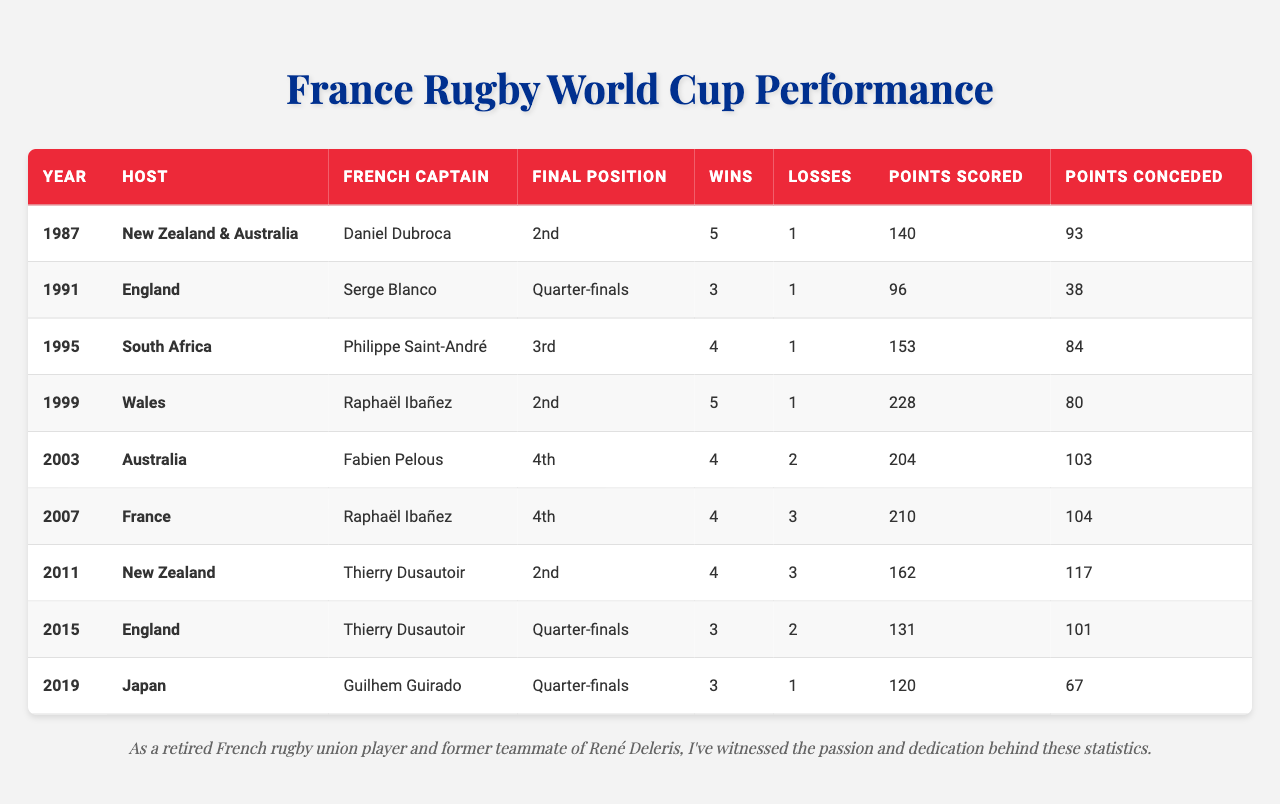What position did France finish in the 1995 Rugby World Cup? In the table, the Final Position for the year 1995 is listed as "3rd."
Answer: 3rd Which year did France score the most points in a Rugby World Cup? Looking at the Points Scored column, the highest value is 228 points in the year 1999.
Answer: 1999 How many wins did France have in the 2011 Rugby World Cup? The table indicates that in 2011, France recorded 4 wins.
Answer: 4 What was the total number of losses for France in the Rugby World Cups held in 2003 and 2007? By adding the losses from both years, 2003 has 2 losses and 2007 has 3 losses, giving a total of 2 + 3 = 5 losses.
Answer: 5 Did France ever finish in 1st place in any Rugby World Cup? Referring to the Final Position column, France never finished in 1st place in any of the tournaments listed.
Answer: No In which World Cup did France have the highest points conceded? Reviewing the Points Conceded column, the highest value is 117 points in the year 2011.
Answer: 2011 What was France’s overall win ratio in the 1999 Rugby World Cup? France won 5 matches and lost 1 match in 1999, totaling 6 matches. The win ratio is 5 wins out of 6 matches, which calculates to 5/6 = 0.833 or approximately 83.3%.
Answer: 83.3% How many points did France concede in the year they finished 4th? There are two instances where France finished 4th: in 2003 (103 points conceded) and 2007 (104 points conceded). Adding them gives 103 + 104 = 207 points conceded.
Answer: 207 What was France's final position and wins in the Rugby World Cup hosted in Japan? The table shows that in the 2019 Rugby World Cup hosted in Japan, France's Final Position was "Quarter-finals" and they had 3 wins.
Answer: Quarter-finals, 3 wins Which year did France have the same French Captain as in 2007? The data indicates that Raphaël Ibañez was the French Captain in both 1999 and 2007.
Answer: 1999, 2007 How many times did France reach the finals of the Rugby World Cup? The Final Position indicates that France reached the finals in 1987, 1999, and 2011, totaling 3 times.
Answer: 3 times 